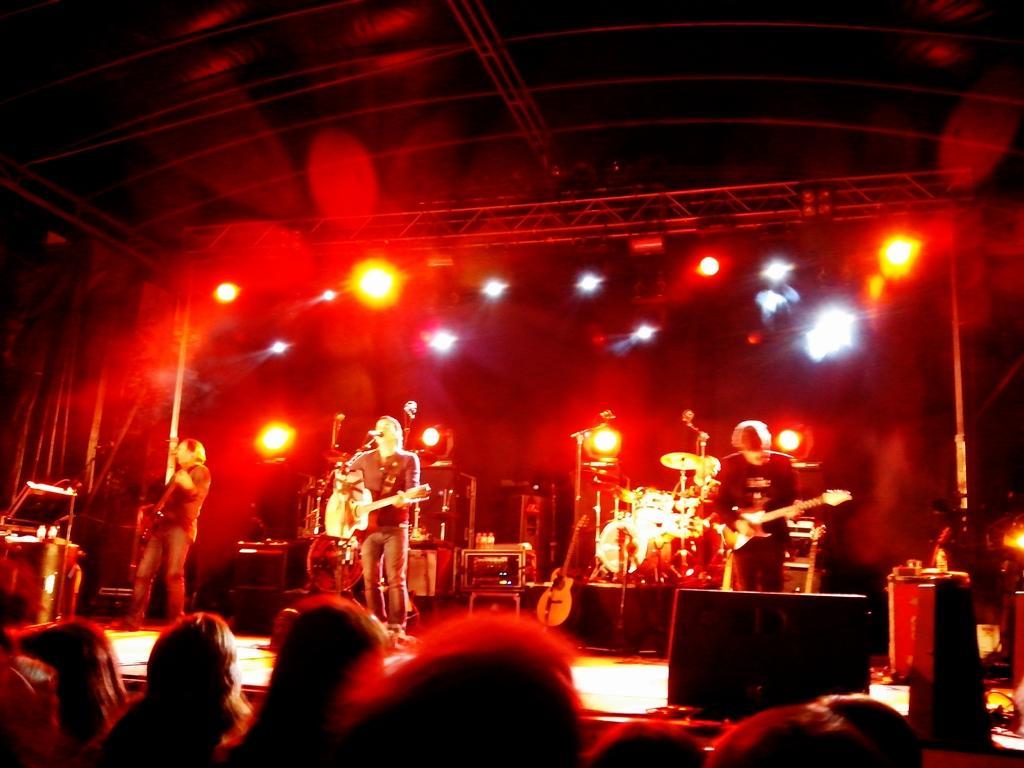How would you summarize this image in a sentence or two? This image is clicked in a concert. There are three men on the dais, performing music. All are playing guitars. In the background, there are many lights in red color. At the bottom, there is a crowd. At the top, there is a roof with stands. 